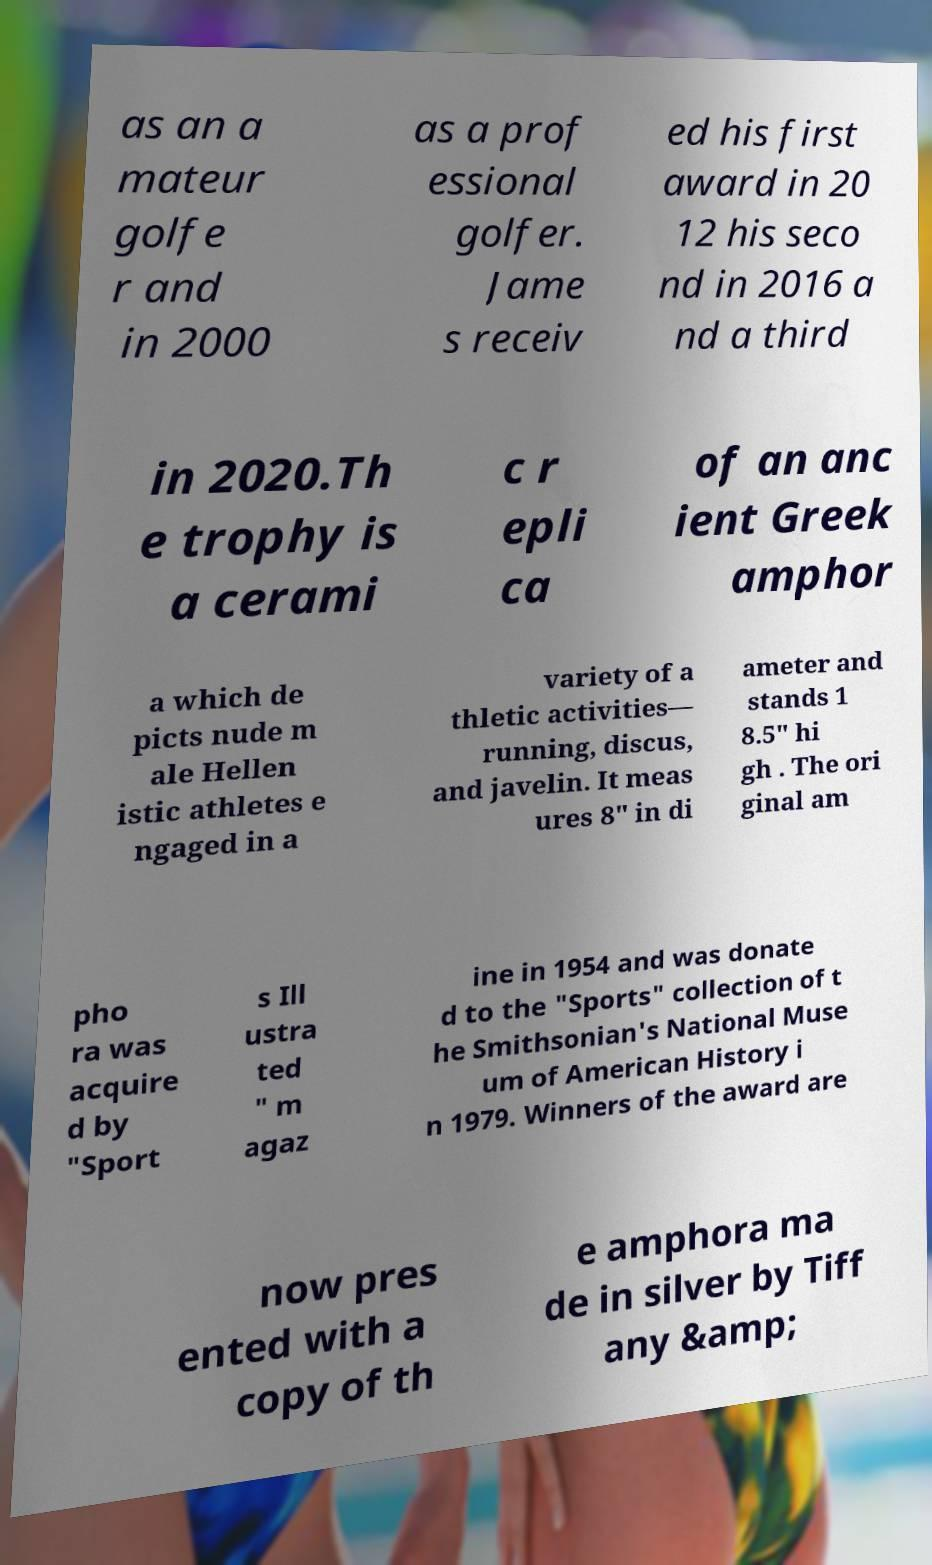There's text embedded in this image that I need extracted. Can you transcribe it verbatim? as an a mateur golfe r and in 2000 as a prof essional golfer. Jame s receiv ed his first award in 20 12 his seco nd in 2016 a nd a third in 2020.Th e trophy is a cerami c r epli ca of an anc ient Greek amphor a which de picts nude m ale Hellen istic athletes e ngaged in a variety of a thletic activities— running, discus, and javelin. It meas ures 8" in di ameter and stands 1 8.5" hi gh . The ori ginal am pho ra was acquire d by "Sport s Ill ustra ted " m agaz ine in 1954 and was donate d to the "Sports" collection of t he Smithsonian's National Muse um of American History i n 1979. Winners of the award are now pres ented with a copy of th e amphora ma de in silver by Tiff any &amp; 